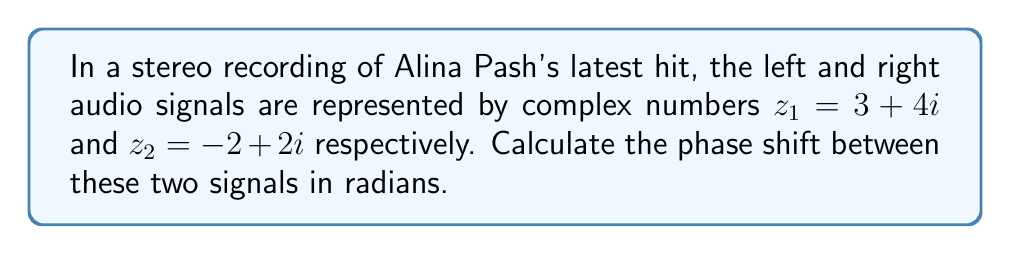Solve this math problem. To determine the phase shift between two audio signals represented as complex numbers, we need to follow these steps:

1) The phase of a complex number $z = a + bi$ is given by $\arctan(\frac{b}{a})$.

2) For the left channel $z_1 = 3 + 4i$:
   Phase $\phi_1 = \arctan(\frac{4}{3})$

3) For the right channel $z_2 = -2 + 2i$:
   Phase $\phi_2 = \arctan(\frac{2}{-2}) + \pi = -\frac{\pi}{4} + \pi = \frac{3\pi}{4}$
   (We add $\pi$ because the real part is negative)

4) The phase shift is the absolute difference between these phases:
   $$\Delta\phi = |\phi_2 - \phi_1| = |\frac{3\pi}{4} - \arctan(\frac{4}{3})|$$

5) Calculate $\arctan(\frac{4}{3})$:
   $$\arctan(\frac{4}{3}) \approx 0.9273 \text{ radians}$$

6) Now we can compute the phase shift:
   $$\Delta\phi = |\frac{3\pi}{4} - 0.9273| \approx 1.4208 \text{ radians}$$
Answer: $1.4208 \text{ radians}$ 